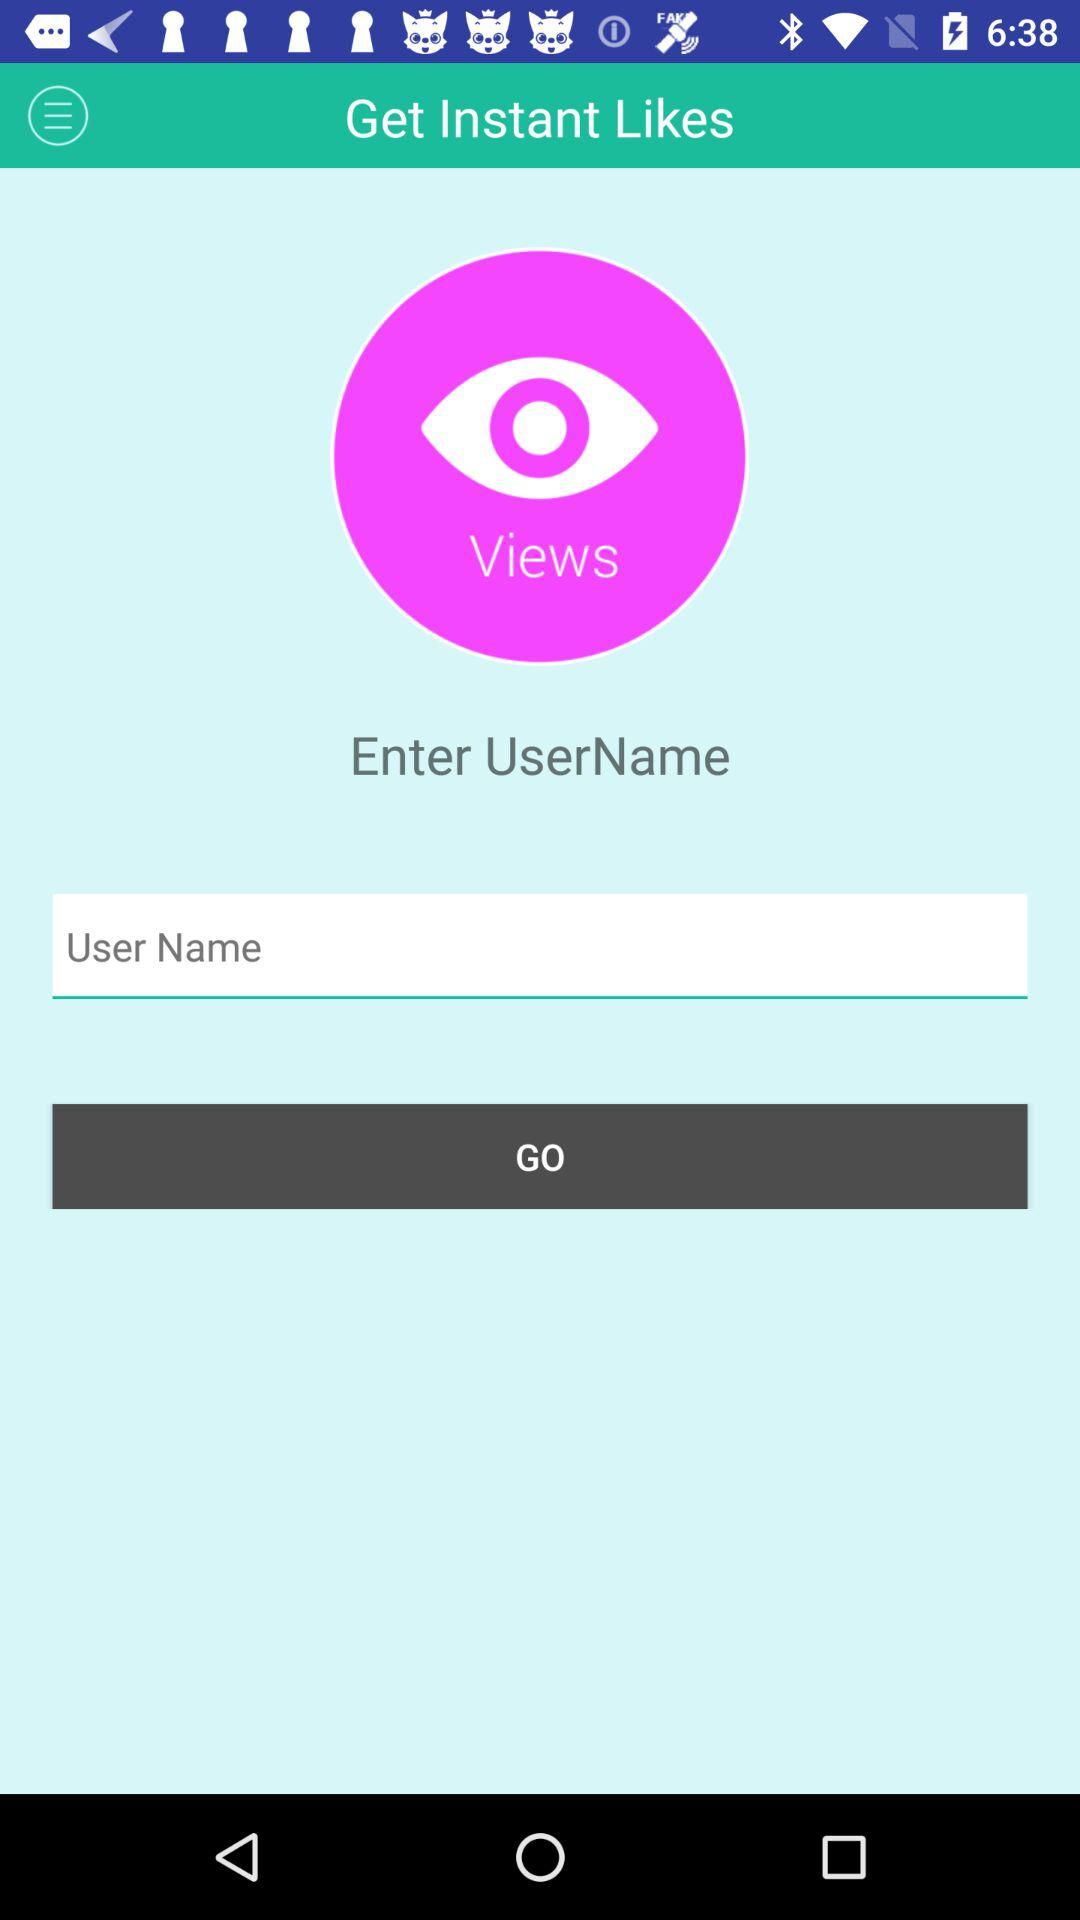Can we write user name?
When the provided information is insufficient, respond with <no answer>. <no answer> 